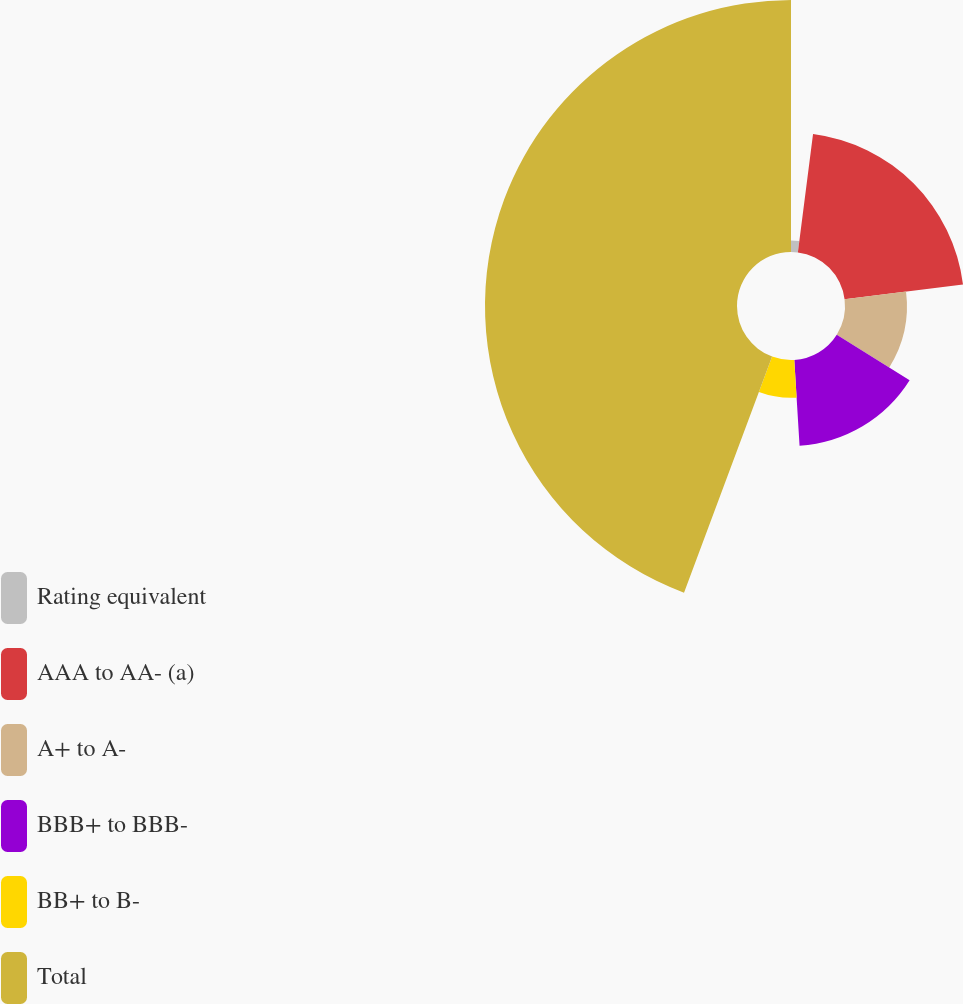Convert chart to OTSL. <chart><loc_0><loc_0><loc_500><loc_500><pie_chart><fcel>Rating equivalent<fcel>AAA to AA- (a)<fcel>A+ to A-<fcel>BBB+ to BBB-<fcel>BB+ to B-<fcel>Total<nl><fcel>2.03%<fcel>20.99%<fcel>10.89%<fcel>15.12%<fcel>6.66%<fcel>44.32%<nl></chart> 